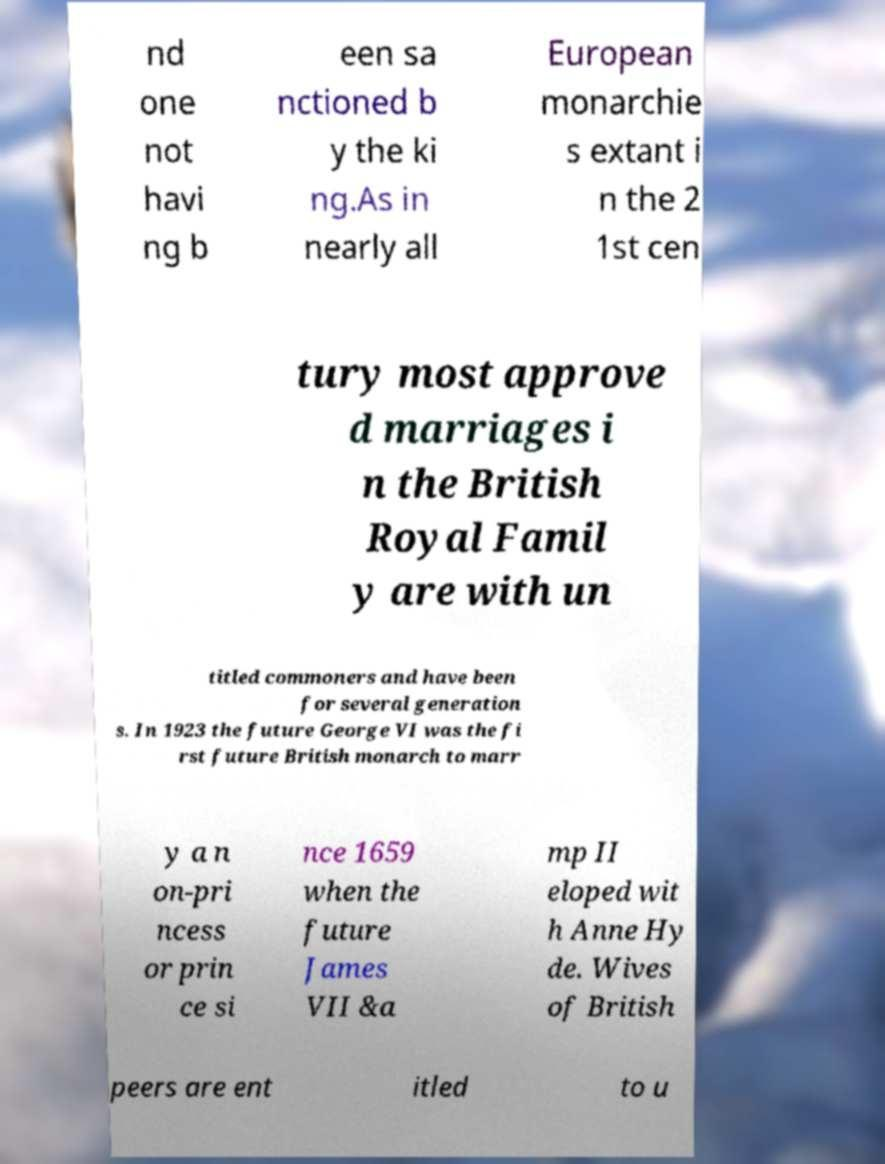Could you extract and type out the text from this image? nd one not havi ng b een sa nctioned b y the ki ng.As in nearly all European monarchie s extant i n the 2 1st cen tury most approve d marriages i n the British Royal Famil y are with un titled commoners and have been for several generation s. In 1923 the future George VI was the fi rst future British monarch to marr y a n on-pri ncess or prin ce si nce 1659 when the future James VII &a mp II eloped wit h Anne Hy de. Wives of British peers are ent itled to u 